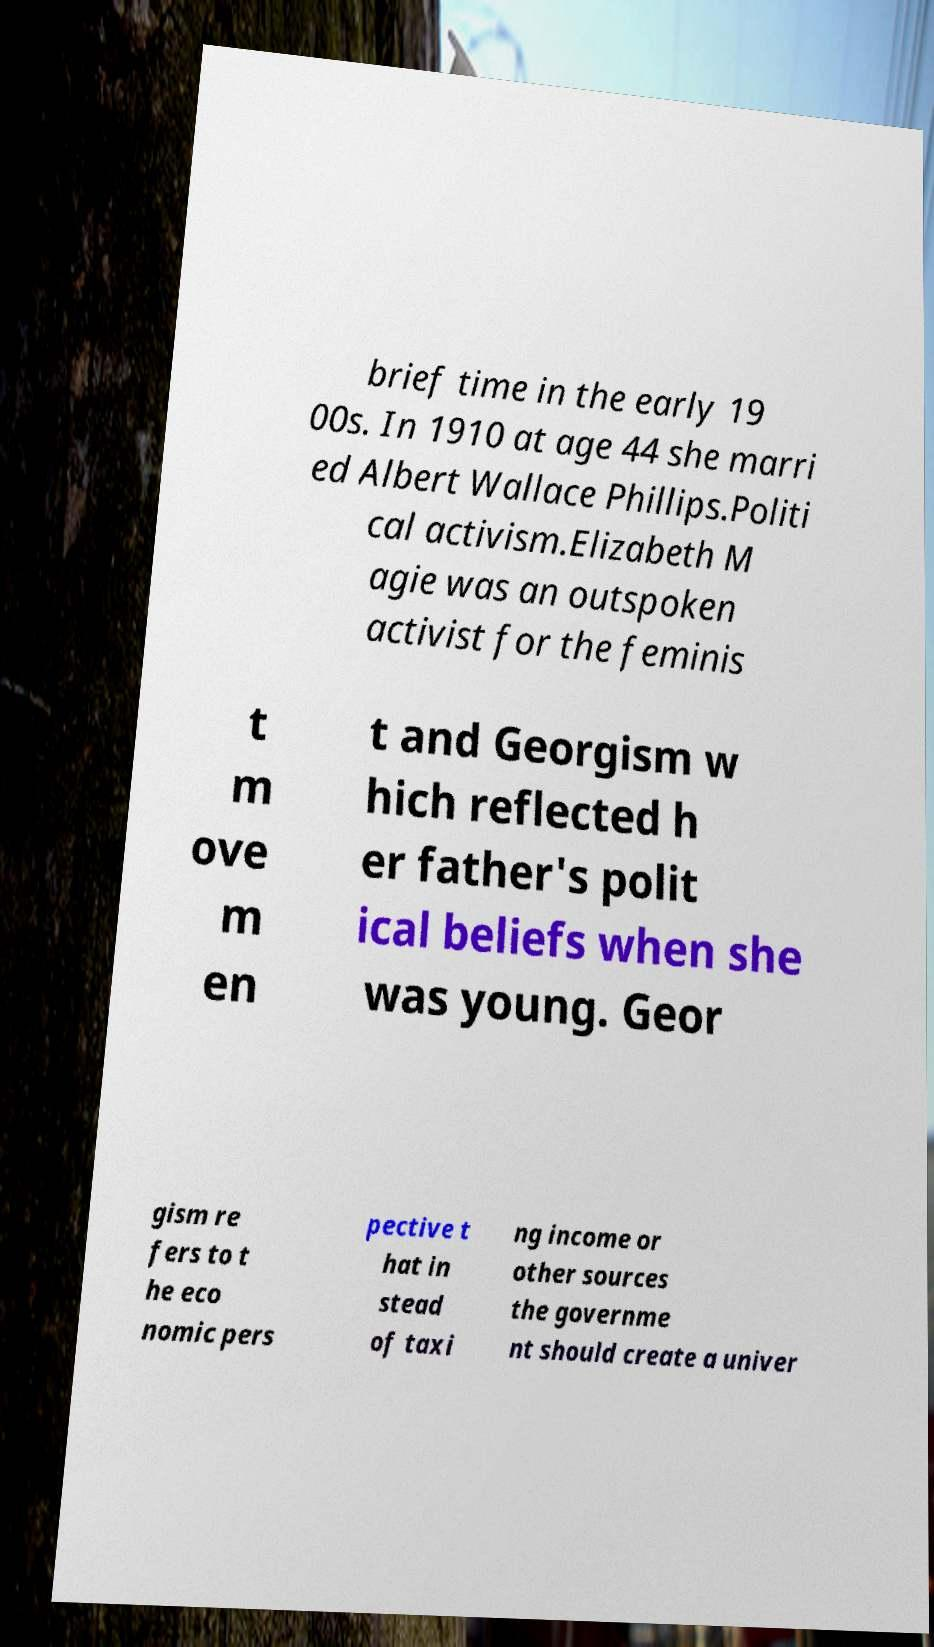Can you read and provide the text displayed in the image?This photo seems to have some interesting text. Can you extract and type it out for me? brief time in the early 19 00s. In 1910 at age 44 she marri ed Albert Wallace Phillips.Politi cal activism.Elizabeth M agie was an outspoken activist for the feminis t m ove m en t and Georgism w hich reflected h er father's polit ical beliefs when she was young. Geor gism re fers to t he eco nomic pers pective t hat in stead of taxi ng income or other sources the governme nt should create a univer 